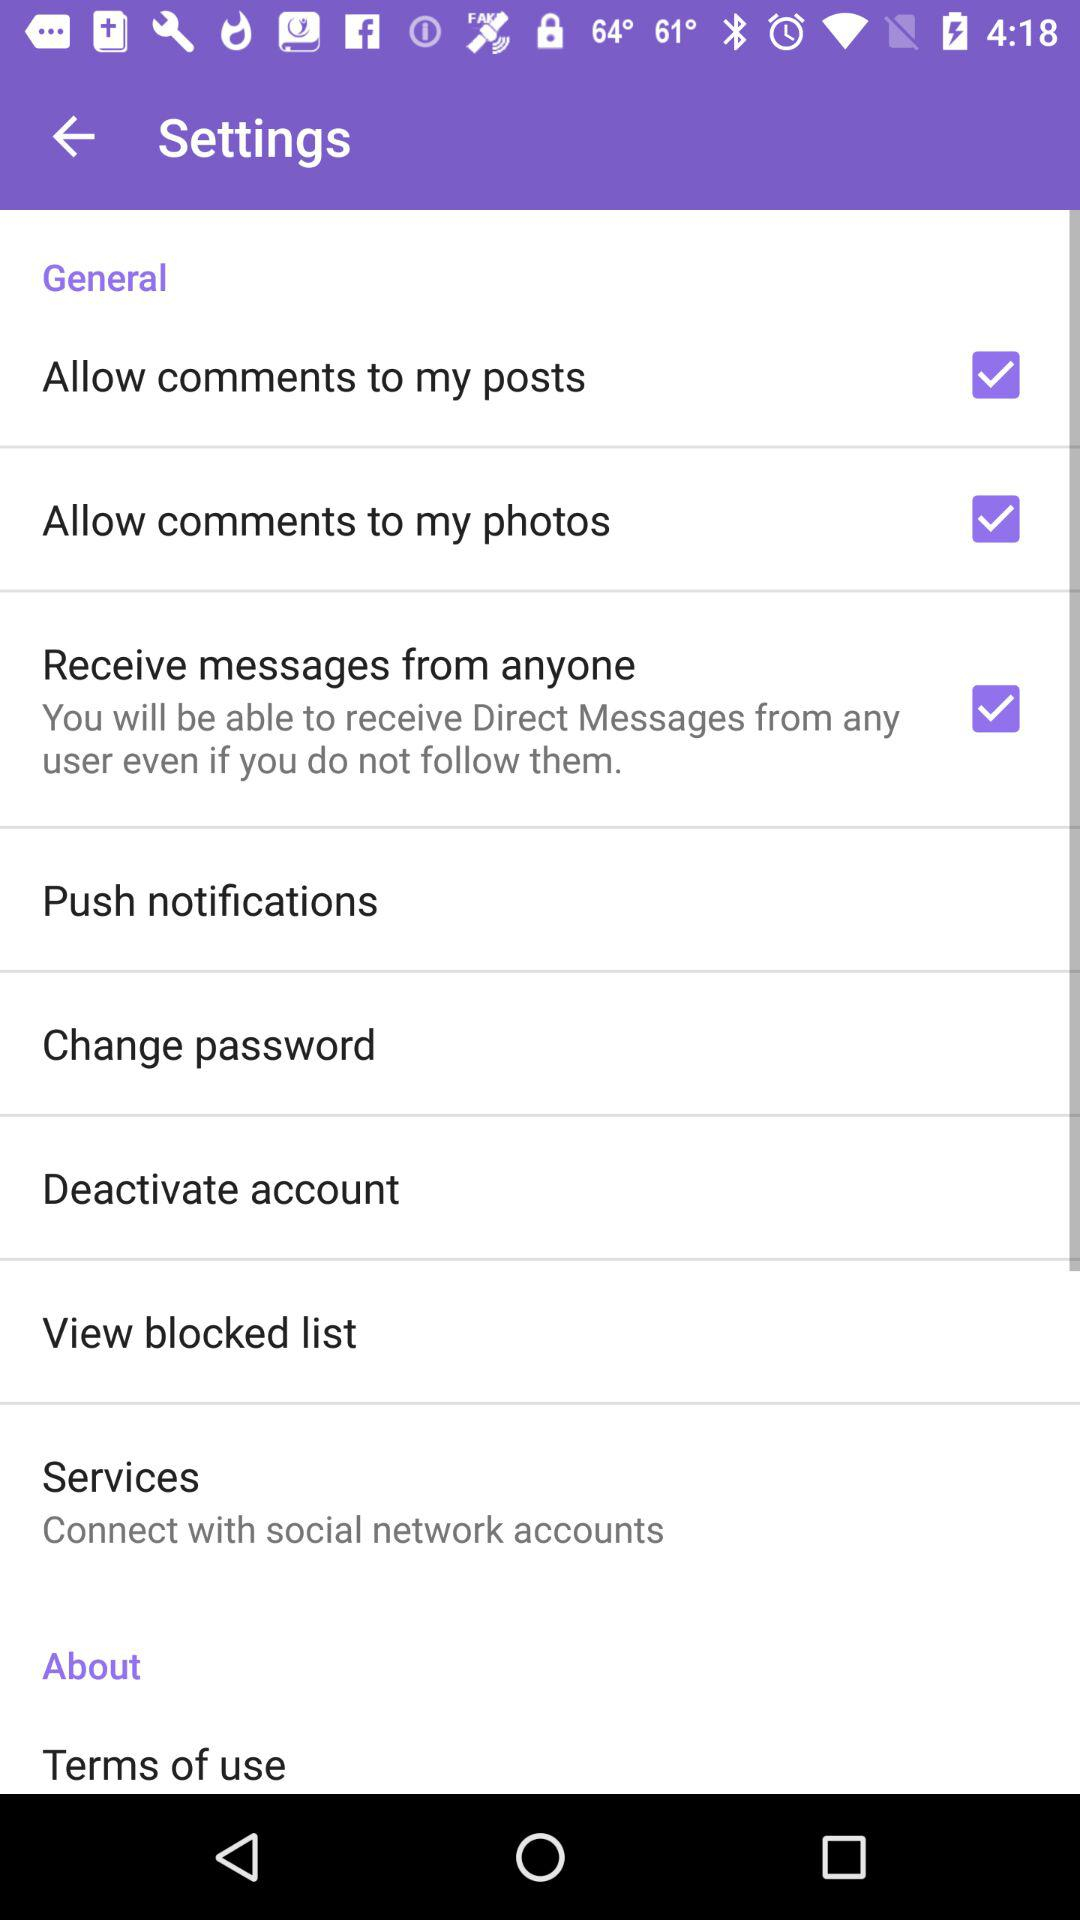What is the status of "Allow comments to my posts"? The status of "Allow comments to my posts" is "on". 